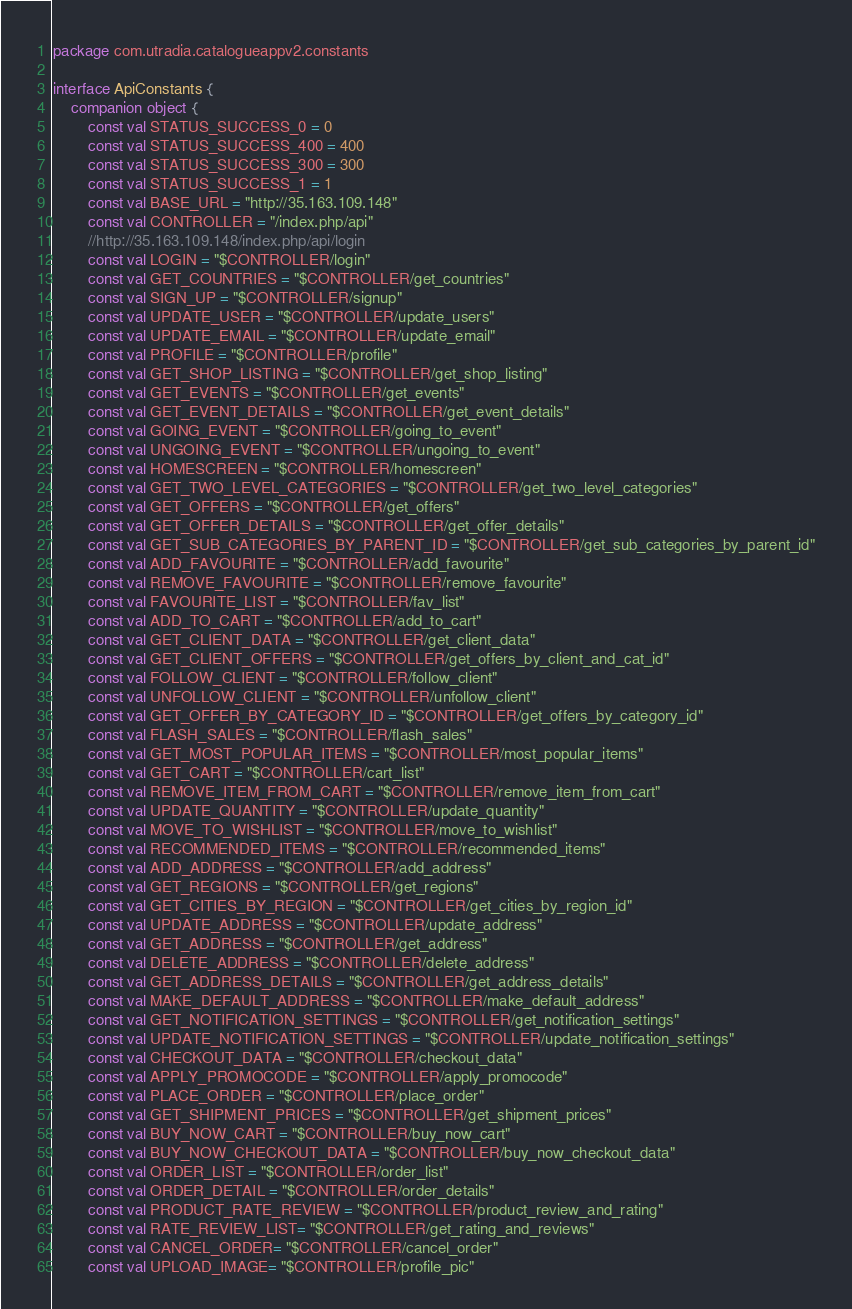<code> <loc_0><loc_0><loc_500><loc_500><_Kotlin_>package com.utradia.catalogueappv2.constants

interface ApiConstants {
    companion object {
        const val STATUS_SUCCESS_0 = 0
        const val STATUS_SUCCESS_400 = 400
        const val STATUS_SUCCESS_300 = 300
        const val STATUS_SUCCESS_1 = 1
        const val BASE_URL = "http://35.163.109.148"
        const val CONTROLLER = "/index.php/api"
        //http://35.163.109.148/index.php/api/login
        const val LOGIN = "$CONTROLLER/login"
        const val GET_COUNTRIES = "$CONTROLLER/get_countries"
        const val SIGN_UP = "$CONTROLLER/signup"
        const val UPDATE_USER = "$CONTROLLER/update_users"
        const val UPDATE_EMAIL = "$CONTROLLER/update_email"
        const val PROFILE = "$CONTROLLER/profile"
        const val GET_SHOP_LISTING = "$CONTROLLER/get_shop_listing"
        const val GET_EVENTS = "$CONTROLLER/get_events"
        const val GET_EVENT_DETAILS = "$CONTROLLER/get_event_details"
        const val GOING_EVENT = "$CONTROLLER/going_to_event"
        const val UNGOING_EVENT = "$CONTROLLER/ungoing_to_event"
        const val HOMESCREEN = "$CONTROLLER/homescreen"
        const val GET_TWO_LEVEL_CATEGORIES = "$CONTROLLER/get_two_level_categories"
        const val GET_OFFERS = "$CONTROLLER/get_offers"
        const val GET_OFFER_DETAILS = "$CONTROLLER/get_offer_details"
        const val GET_SUB_CATEGORIES_BY_PARENT_ID = "$CONTROLLER/get_sub_categories_by_parent_id"
        const val ADD_FAVOURITE = "$CONTROLLER/add_favourite"
        const val REMOVE_FAVOURITE = "$CONTROLLER/remove_favourite"
        const val FAVOURITE_LIST = "$CONTROLLER/fav_list"
        const val ADD_TO_CART = "$CONTROLLER/add_to_cart"
        const val GET_CLIENT_DATA = "$CONTROLLER/get_client_data"
        const val GET_CLIENT_OFFERS = "$CONTROLLER/get_offers_by_client_and_cat_id"
        const val FOLLOW_CLIENT = "$CONTROLLER/follow_client"
        const val UNFOLLOW_CLIENT = "$CONTROLLER/unfollow_client"
        const val GET_OFFER_BY_CATEGORY_ID = "$CONTROLLER/get_offers_by_category_id"
        const val FLASH_SALES = "$CONTROLLER/flash_sales"
        const val GET_MOST_POPULAR_ITEMS = "$CONTROLLER/most_popular_items"
        const val GET_CART = "$CONTROLLER/cart_list"
        const val REMOVE_ITEM_FROM_CART = "$CONTROLLER/remove_item_from_cart"
        const val UPDATE_QUANTITY = "$CONTROLLER/update_quantity"
        const val MOVE_TO_WISHLIST = "$CONTROLLER/move_to_wishlist"
        const val RECOMMENDED_ITEMS = "$CONTROLLER/recommended_items"
        const val ADD_ADDRESS = "$CONTROLLER/add_address"
        const val GET_REGIONS = "$CONTROLLER/get_regions"
        const val GET_CITIES_BY_REGION = "$CONTROLLER/get_cities_by_region_id"
        const val UPDATE_ADDRESS = "$CONTROLLER/update_address"
        const val GET_ADDRESS = "$CONTROLLER/get_address"
        const val DELETE_ADDRESS = "$CONTROLLER/delete_address"
        const val GET_ADDRESS_DETAILS = "$CONTROLLER/get_address_details"
        const val MAKE_DEFAULT_ADDRESS = "$CONTROLLER/make_default_address"
        const val GET_NOTIFICATION_SETTINGS = "$CONTROLLER/get_notification_settings"
        const val UPDATE_NOTIFICATION_SETTINGS = "$CONTROLLER/update_notification_settings"
        const val CHECKOUT_DATA = "$CONTROLLER/checkout_data"
        const val APPLY_PROMOCODE = "$CONTROLLER/apply_promocode"
        const val PLACE_ORDER = "$CONTROLLER/place_order"
        const val GET_SHIPMENT_PRICES = "$CONTROLLER/get_shipment_prices"
        const val BUY_NOW_CART = "$CONTROLLER/buy_now_cart"
        const val BUY_NOW_CHECKOUT_DATA = "$CONTROLLER/buy_now_checkout_data"
        const val ORDER_LIST = "$CONTROLLER/order_list"
        const val ORDER_DETAIL = "$CONTROLLER/order_details"
        const val PRODUCT_RATE_REVIEW = "$CONTROLLER/product_review_and_rating"
        const val RATE_REVIEW_LIST= "$CONTROLLER/get_rating_and_reviews"
        const val CANCEL_ORDER= "$CONTROLLER/cancel_order"
        const val UPLOAD_IMAGE= "$CONTROLLER/profile_pic"</code> 